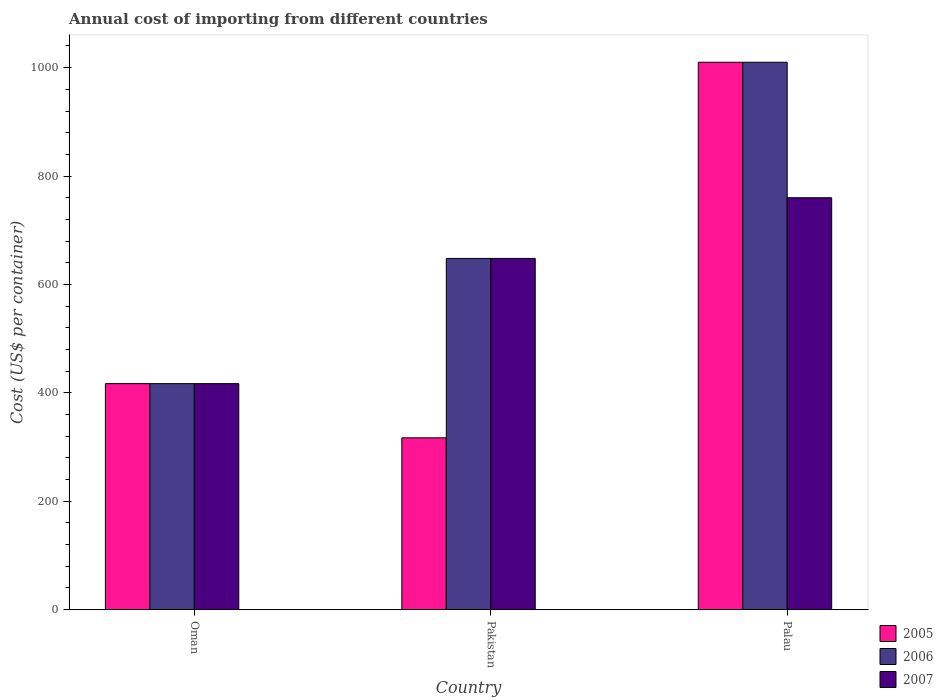How many different coloured bars are there?
Your response must be concise. 3. How many groups of bars are there?
Give a very brief answer. 3. Are the number of bars per tick equal to the number of legend labels?
Keep it short and to the point. Yes. Are the number of bars on each tick of the X-axis equal?
Your response must be concise. Yes. What is the label of the 1st group of bars from the left?
Offer a terse response. Oman. In how many cases, is the number of bars for a given country not equal to the number of legend labels?
Give a very brief answer. 0. What is the total annual cost of importing in 2007 in Oman?
Your answer should be very brief. 417. Across all countries, what is the maximum total annual cost of importing in 2005?
Your response must be concise. 1010. Across all countries, what is the minimum total annual cost of importing in 2005?
Your answer should be very brief. 317. In which country was the total annual cost of importing in 2007 maximum?
Offer a very short reply. Palau. In which country was the total annual cost of importing in 2006 minimum?
Provide a short and direct response. Oman. What is the total total annual cost of importing in 2006 in the graph?
Offer a very short reply. 2075. What is the difference between the total annual cost of importing in 2005 in Pakistan and the total annual cost of importing in 2006 in Palau?
Make the answer very short. -693. What is the average total annual cost of importing in 2005 per country?
Your response must be concise. 581.33. What is the difference between the total annual cost of importing of/in 2005 and total annual cost of importing of/in 2006 in Pakistan?
Keep it short and to the point. -331. In how many countries, is the total annual cost of importing in 2005 greater than 800 US$?
Offer a terse response. 1. What is the ratio of the total annual cost of importing in 2005 in Oman to that in Pakistan?
Keep it short and to the point. 1.32. Is the total annual cost of importing in 2006 in Pakistan less than that in Palau?
Your answer should be compact. Yes. What is the difference between the highest and the second highest total annual cost of importing in 2005?
Keep it short and to the point. -593. What is the difference between the highest and the lowest total annual cost of importing in 2005?
Make the answer very short. 693. In how many countries, is the total annual cost of importing in 2005 greater than the average total annual cost of importing in 2005 taken over all countries?
Provide a succinct answer. 1. What does the 1st bar from the right in Pakistan represents?
Make the answer very short. 2007. How many bars are there?
Provide a short and direct response. 9. How many countries are there in the graph?
Provide a succinct answer. 3. Are the values on the major ticks of Y-axis written in scientific E-notation?
Provide a succinct answer. No. Does the graph contain any zero values?
Make the answer very short. No. Does the graph contain grids?
Provide a short and direct response. No. Where does the legend appear in the graph?
Your answer should be compact. Bottom right. How are the legend labels stacked?
Your response must be concise. Vertical. What is the title of the graph?
Ensure brevity in your answer.  Annual cost of importing from different countries. What is the label or title of the X-axis?
Offer a very short reply. Country. What is the label or title of the Y-axis?
Ensure brevity in your answer.  Cost (US$ per container). What is the Cost (US$ per container) of 2005 in Oman?
Your response must be concise. 417. What is the Cost (US$ per container) in 2006 in Oman?
Your response must be concise. 417. What is the Cost (US$ per container) in 2007 in Oman?
Your response must be concise. 417. What is the Cost (US$ per container) in 2005 in Pakistan?
Ensure brevity in your answer.  317. What is the Cost (US$ per container) of 2006 in Pakistan?
Your answer should be compact. 648. What is the Cost (US$ per container) of 2007 in Pakistan?
Your response must be concise. 648. What is the Cost (US$ per container) of 2005 in Palau?
Provide a short and direct response. 1010. What is the Cost (US$ per container) in 2006 in Palau?
Offer a very short reply. 1010. What is the Cost (US$ per container) of 2007 in Palau?
Offer a terse response. 760. Across all countries, what is the maximum Cost (US$ per container) in 2005?
Make the answer very short. 1010. Across all countries, what is the maximum Cost (US$ per container) of 2006?
Your response must be concise. 1010. Across all countries, what is the maximum Cost (US$ per container) of 2007?
Provide a short and direct response. 760. Across all countries, what is the minimum Cost (US$ per container) in 2005?
Provide a succinct answer. 317. Across all countries, what is the minimum Cost (US$ per container) of 2006?
Provide a short and direct response. 417. Across all countries, what is the minimum Cost (US$ per container) in 2007?
Give a very brief answer. 417. What is the total Cost (US$ per container) in 2005 in the graph?
Your answer should be very brief. 1744. What is the total Cost (US$ per container) of 2006 in the graph?
Keep it short and to the point. 2075. What is the total Cost (US$ per container) of 2007 in the graph?
Your answer should be compact. 1825. What is the difference between the Cost (US$ per container) in 2005 in Oman and that in Pakistan?
Keep it short and to the point. 100. What is the difference between the Cost (US$ per container) in 2006 in Oman and that in Pakistan?
Make the answer very short. -231. What is the difference between the Cost (US$ per container) of 2007 in Oman and that in Pakistan?
Offer a very short reply. -231. What is the difference between the Cost (US$ per container) of 2005 in Oman and that in Palau?
Your answer should be very brief. -593. What is the difference between the Cost (US$ per container) in 2006 in Oman and that in Palau?
Your answer should be compact. -593. What is the difference between the Cost (US$ per container) of 2007 in Oman and that in Palau?
Your answer should be very brief. -343. What is the difference between the Cost (US$ per container) of 2005 in Pakistan and that in Palau?
Your answer should be very brief. -693. What is the difference between the Cost (US$ per container) in 2006 in Pakistan and that in Palau?
Offer a terse response. -362. What is the difference between the Cost (US$ per container) in 2007 in Pakistan and that in Palau?
Give a very brief answer. -112. What is the difference between the Cost (US$ per container) in 2005 in Oman and the Cost (US$ per container) in 2006 in Pakistan?
Offer a terse response. -231. What is the difference between the Cost (US$ per container) of 2005 in Oman and the Cost (US$ per container) of 2007 in Pakistan?
Make the answer very short. -231. What is the difference between the Cost (US$ per container) of 2006 in Oman and the Cost (US$ per container) of 2007 in Pakistan?
Give a very brief answer. -231. What is the difference between the Cost (US$ per container) in 2005 in Oman and the Cost (US$ per container) in 2006 in Palau?
Provide a succinct answer. -593. What is the difference between the Cost (US$ per container) in 2005 in Oman and the Cost (US$ per container) in 2007 in Palau?
Make the answer very short. -343. What is the difference between the Cost (US$ per container) of 2006 in Oman and the Cost (US$ per container) of 2007 in Palau?
Give a very brief answer. -343. What is the difference between the Cost (US$ per container) in 2005 in Pakistan and the Cost (US$ per container) in 2006 in Palau?
Your answer should be very brief. -693. What is the difference between the Cost (US$ per container) in 2005 in Pakistan and the Cost (US$ per container) in 2007 in Palau?
Keep it short and to the point. -443. What is the difference between the Cost (US$ per container) in 2006 in Pakistan and the Cost (US$ per container) in 2007 in Palau?
Give a very brief answer. -112. What is the average Cost (US$ per container) of 2005 per country?
Keep it short and to the point. 581.33. What is the average Cost (US$ per container) in 2006 per country?
Your response must be concise. 691.67. What is the average Cost (US$ per container) in 2007 per country?
Provide a short and direct response. 608.33. What is the difference between the Cost (US$ per container) in 2006 and Cost (US$ per container) in 2007 in Oman?
Keep it short and to the point. 0. What is the difference between the Cost (US$ per container) of 2005 and Cost (US$ per container) of 2006 in Pakistan?
Offer a terse response. -331. What is the difference between the Cost (US$ per container) of 2005 and Cost (US$ per container) of 2007 in Pakistan?
Provide a succinct answer. -331. What is the difference between the Cost (US$ per container) in 2005 and Cost (US$ per container) in 2006 in Palau?
Keep it short and to the point. 0. What is the difference between the Cost (US$ per container) of 2005 and Cost (US$ per container) of 2007 in Palau?
Your response must be concise. 250. What is the difference between the Cost (US$ per container) of 2006 and Cost (US$ per container) of 2007 in Palau?
Offer a very short reply. 250. What is the ratio of the Cost (US$ per container) in 2005 in Oman to that in Pakistan?
Provide a short and direct response. 1.32. What is the ratio of the Cost (US$ per container) of 2006 in Oman to that in Pakistan?
Your response must be concise. 0.64. What is the ratio of the Cost (US$ per container) of 2007 in Oman to that in Pakistan?
Give a very brief answer. 0.64. What is the ratio of the Cost (US$ per container) in 2005 in Oman to that in Palau?
Ensure brevity in your answer.  0.41. What is the ratio of the Cost (US$ per container) of 2006 in Oman to that in Palau?
Your answer should be compact. 0.41. What is the ratio of the Cost (US$ per container) in 2007 in Oman to that in Palau?
Your answer should be compact. 0.55. What is the ratio of the Cost (US$ per container) in 2005 in Pakistan to that in Palau?
Your answer should be compact. 0.31. What is the ratio of the Cost (US$ per container) in 2006 in Pakistan to that in Palau?
Your answer should be compact. 0.64. What is the ratio of the Cost (US$ per container) of 2007 in Pakistan to that in Palau?
Make the answer very short. 0.85. What is the difference between the highest and the second highest Cost (US$ per container) in 2005?
Offer a terse response. 593. What is the difference between the highest and the second highest Cost (US$ per container) in 2006?
Give a very brief answer. 362. What is the difference between the highest and the second highest Cost (US$ per container) of 2007?
Make the answer very short. 112. What is the difference between the highest and the lowest Cost (US$ per container) in 2005?
Your answer should be very brief. 693. What is the difference between the highest and the lowest Cost (US$ per container) in 2006?
Your answer should be compact. 593. What is the difference between the highest and the lowest Cost (US$ per container) of 2007?
Provide a short and direct response. 343. 